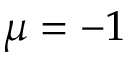Convert formula to latex. <formula><loc_0><loc_0><loc_500><loc_500>\mu = - 1</formula> 